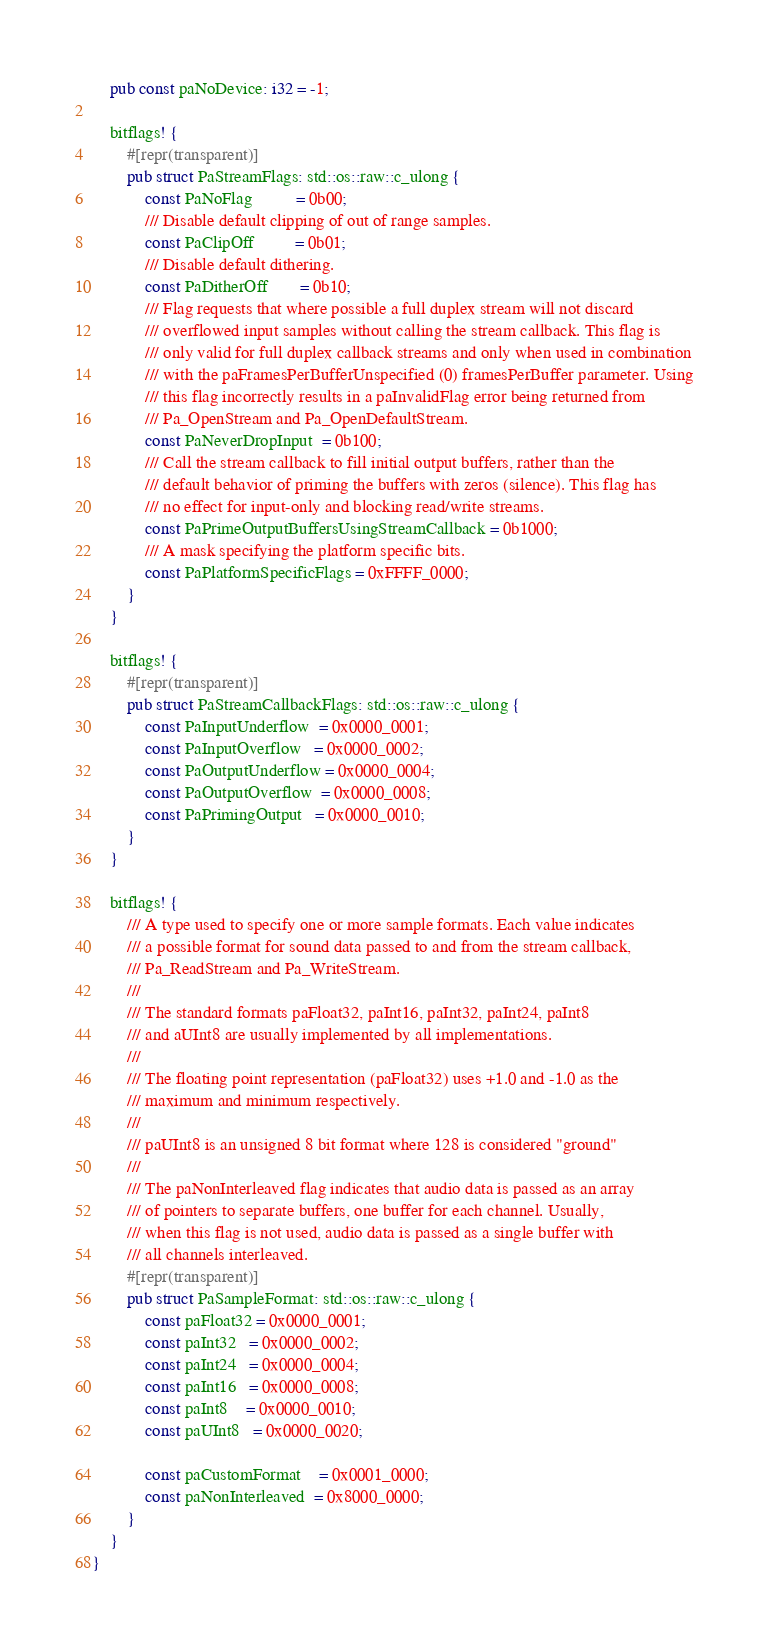<code> <loc_0><loc_0><loc_500><loc_500><_Rust_>
    pub const paNoDevice: i32 = -1;

    bitflags! {
        #[repr(transparent)]
        pub struct PaStreamFlags: std::os::raw::c_ulong {
            const PaNoFlag          = 0b00;
            /// Disable default clipping of out of range samples.
            const PaClipOff         = 0b01;
            /// Disable default dithering.
            const PaDitherOff       = 0b10;
            /// Flag requests that where possible a full duplex stream will not discard
            /// overflowed input samples without calling the stream callback. This flag is
            /// only valid for full duplex callback streams and only when used in combination
            /// with the paFramesPerBufferUnspecified (0) framesPerBuffer parameter. Using
            /// this flag incorrectly results in a paInvalidFlag error being returned from
            /// Pa_OpenStream and Pa_OpenDefaultStream.
            const PaNeverDropInput  = 0b100;
            /// Call the stream callback to fill initial output buffers, rather than the
            /// default behavior of priming the buffers with zeros (silence). This flag has
            /// no effect for input-only and blocking read/write streams.
            const PaPrimeOutputBuffersUsingStreamCallback = 0b1000;
            /// A mask specifying the platform specific bits.
            const PaPlatformSpecificFlags = 0xFFFF_0000;
        }
    }

    bitflags! {
        #[repr(transparent)]
        pub struct PaStreamCallbackFlags: std::os::raw::c_ulong {
            const PaInputUnderflow  = 0x0000_0001;
            const PaInputOverflow   = 0x0000_0002;
            const PaOutputUnderflow = 0x0000_0004;
            const PaOutputOverflow  = 0x0000_0008;
            const PaPrimingOutput   = 0x0000_0010;
        }
    }

    bitflags! {
        /// A type used to specify one or more sample formats. Each value indicates
        /// a possible format for sound data passed to and from the stream callback,
        /// Pa_ReadStream and Pa_WriteStream.
        ///
        /// The standard formats paFloat32, paInt16, paInt32, paInt24, paInt8
        /// and aUInt8 are usually implemented by all implementations.
        ///
        /// The floating point representation (paFloat32) uses +1.0 and -1.0 as the
        /// maximum and minimum respectively.
        ///
        /// paUInt8 is an unsigned 8 bit format where 128 is considered "ground"
        ///
        /// The paNonInterleaved flag indicates that audio data is passed as an array
        /// of pointers to separate buffers, one buffer for each channel. Usually,
        /// when this flag is not used, audio data is passed as a single buffer with
        /// all channels interleaved.
        #[repr(transparent)]
        pub struct PaSampleFormat: std::os::raw::c_ulong {
            const paFloat32 = 0x0000_0001;
            const paInt32   = 0x0000_0002;
            const paInt24   = 0x0000_0004;
            const paInt16   = 0x0000_0008;
            const paInt8    = 0x0000_0010;
            const paUInt8   = 0x0000_0020;

            const paCustomFormat    = 0x0001_0000;
            const paNonInterleaved  = 0x8000_0000;
        }
    }
}
</code> 